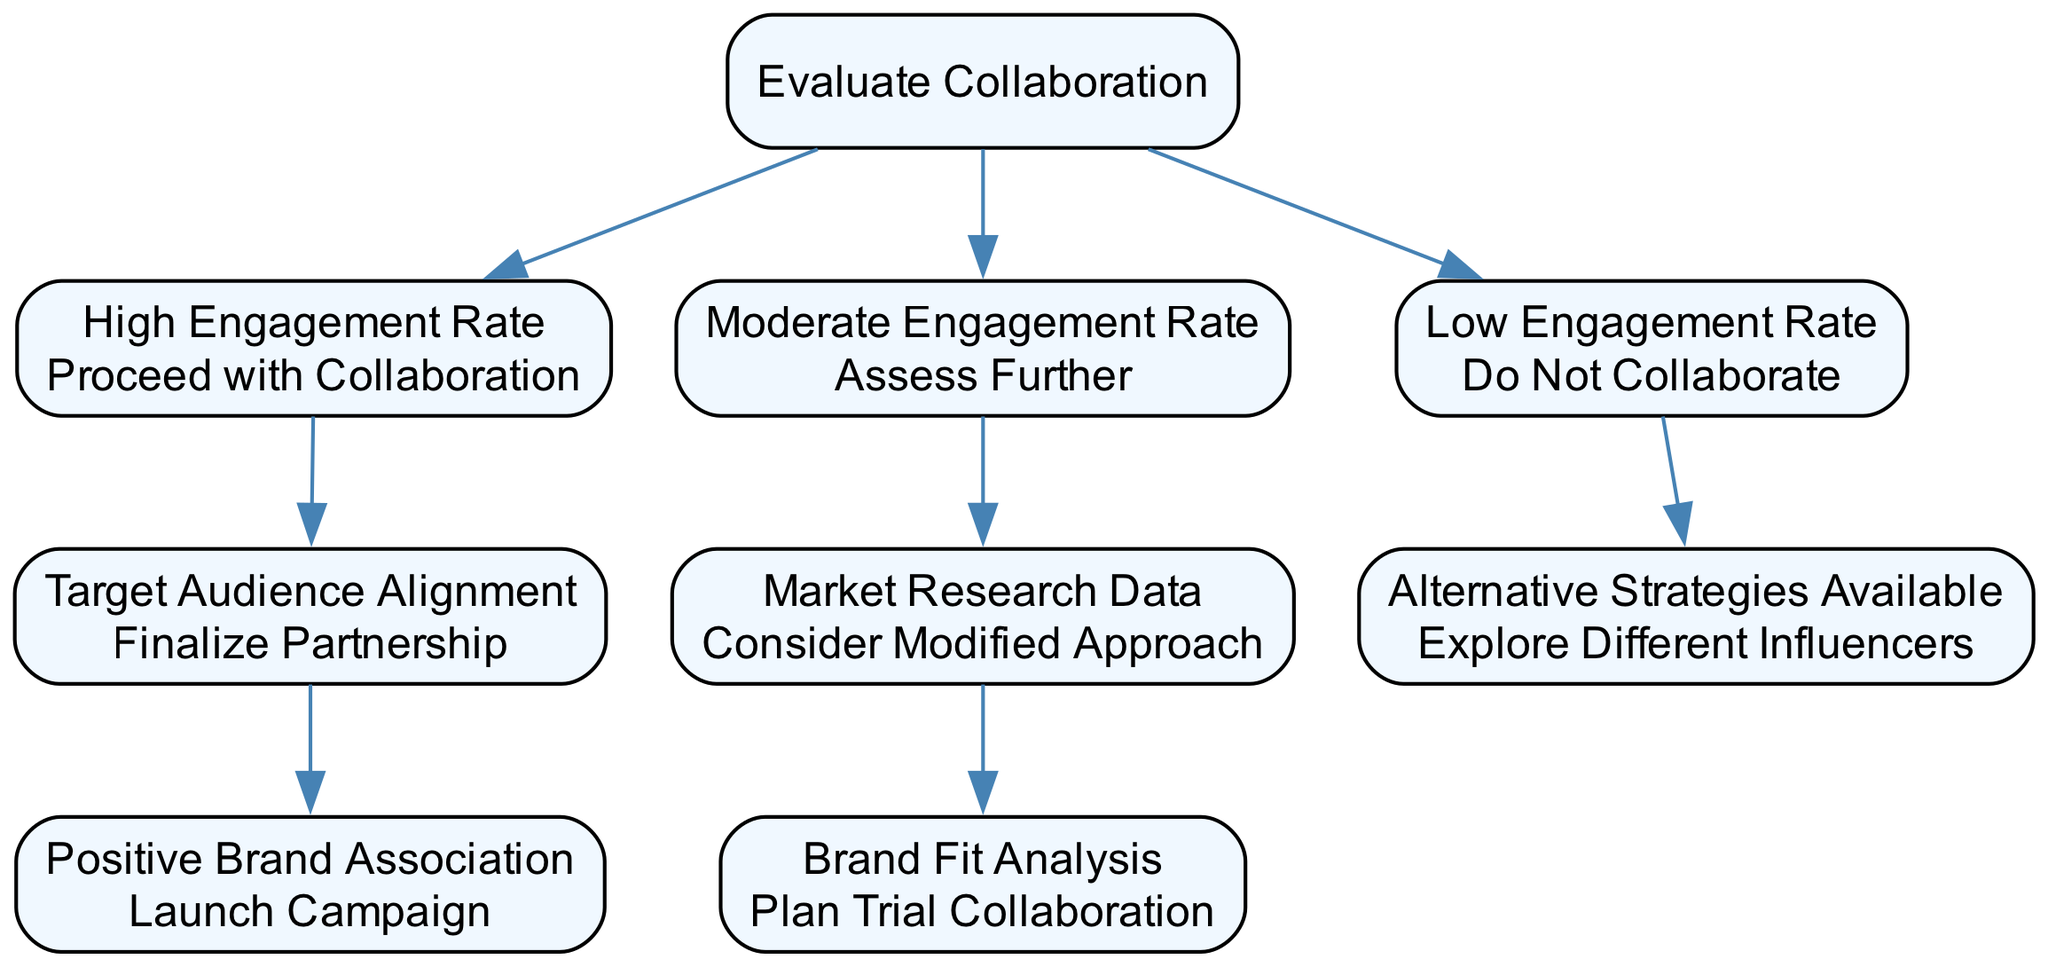What is the starting node of the decision tree? The starting node, which is also the root of the decision tree, is labeled "Evaluate Collaboration."
Answer: Evaluate Collaboration How many main conditions are there at the first decision level? There are three main conditions at the first decision level: "High Engagement Rate," "Moderate Engagement Rate," and "Low Engagement Rate."
Answer: Three What action is taken for a 'High Engagement Rate'? For a 'High Engagement Rate', the action taken is to "Proceed with Collaboration."
Answer: Proceed with Collaboration Which action follows after assessing "Market Research Data"? After assessing "Market Research Data," the next action is to "Consider Modified Approach."
Answer: Consider Modified Approach If the engagement rate is 'Low', what is the next step according to the decision tree? If the engagement rate is 'Low', the next step is to check if "Alternative Strategies Available."
Answer: Explore Different Influencers What happens after "Finalize Partnership"? After "Finalize Partnership," the next action is to "Launch Campaign."
Answer: Launch Campaign What does a 'Moderate Engagement Rate' lead to in the decision tree? A 'Moderate Engagement Rate' leads to an assessment labeled "Assess Further."
Answer: Assess Further What is the final action taken if there is a 'Low Engagement Rate' and no alternative strategies? The final action remains "Explore Different Influencers" if there is a 'Low Engagement Rate' and alternative strategies.
Answer: Explore Different Influencers What is the outcome if there is a 'High Engagement Rate' but no positive brand association? The flow would not progress to finalize a partnership in this case since "Positive Brand Association" is a condition that must be satisfied next; therefore, no outcome is specified for this situation.
Answer: No outcome specified 